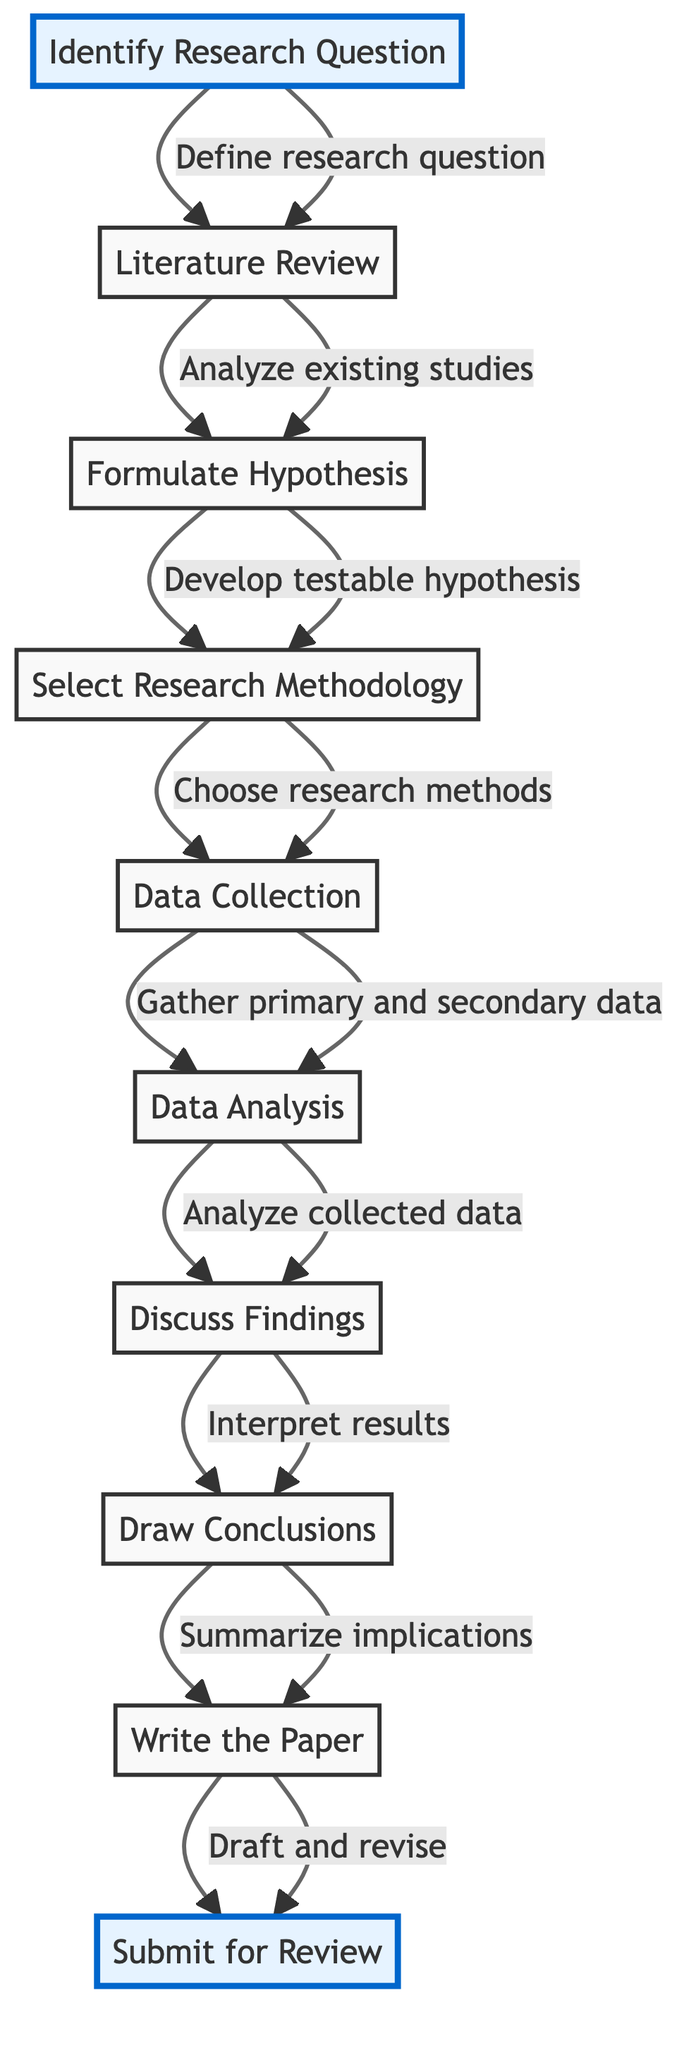What is the first step in creating the academic paper? The first step in the diagram is "Identify Research Question," which is where the process begins. This step focuses on defining how political ideology influences contemporary music composition.
Answer: Identify Research Question How many total steps are in the diagram? Counting all the elements in the flow chart, we find there are ten steps represented in the diagram. Each step corresponds to a distinct phase in the process of creating the academic paper.
Answer: 10 What follows after the Literature Review? Following the "Literature Review" step, the next step in the flow chart is "Formulate Hypothesis," indicating this is the logical progression after reviewing existing studies.
Answer: Formulate Hypothesis What type of data is collected in the Data Collection step? In the "Data Collection" step, it specifies gathering "primary and secondary data," which refers to firsthand and derived data sources relevant to the research.
Answer: Primary and secondary data Which two steps are highlighted in the diagram? The diagram highlights "Identify Research Question" at the start and "Submit for Review" at the end. These highlights show notable points in the research process.
Answer: Identify Research Question, Submit for Review In which step are the results interpreted? The results are interpreted in the "Discuss Findings" step, where researchers analyze what the collected data reveals about political ideologies in music.
Answer: Discuss Findings What is the last action taken in the research process? The last action in the research process is "Submit for Review," where the completed paper is sent to a journal or conference for peer review.
Answer: Submit for Review What is the relationship between Formulate Hypothesis and Select Research Methodology? The relationship between "Formulate Hypothesis" and "Select Research Methodology" is that "Formulate Hypothesis" leads into "Select Research Methodology," meaning a hypothesis is developed before choosing the methods for data collection.
Answer: Formulation leads to selection How does the Data Analysis step impact subsequent steps? The "Data Analysis" step informs the "Discuss Findings" step, as the analysis results shape the interpretation of the data in the context of political ideologies in music.
Answer: Data analysis informs discussion 